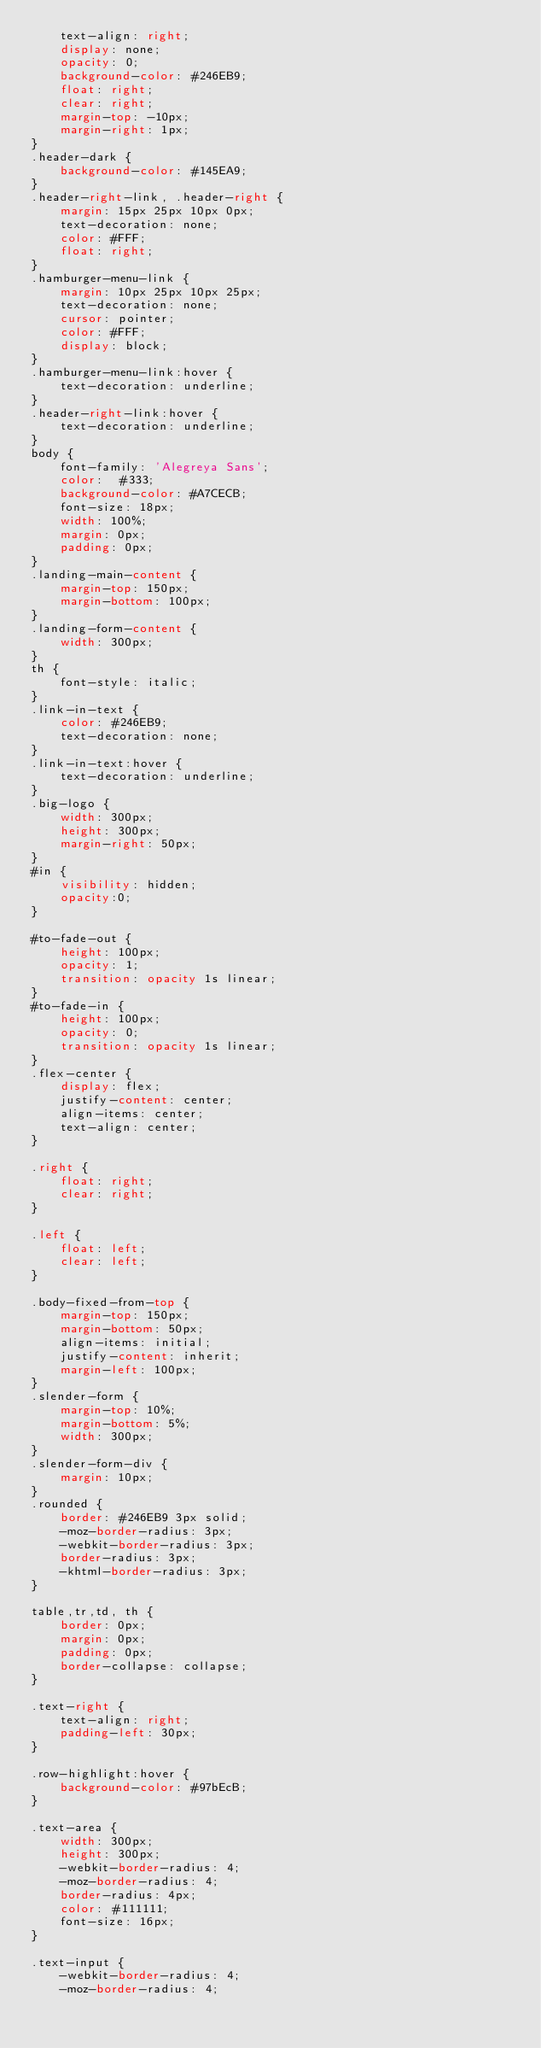<code> <loc_0><loc_0><loc_500><loc_500><_CSS_>    text-align: right;
    display: none;
    opacity: 0;
    background-color: #246EB9;
    float: right;
    clear: right;
    margin-top: -10px;
    margin-right: 1px;
}
.header-dark {
    background-color: #145EA9;
}
.header-right-link, .header-right {
    margin: 15px 25px 10px 0px;
    text-decoration: none;
    color: #FFF;
    float: right;
}
.hamburger-menu-link {
    margin: 10px 25px 10px 25px;
    text-decoration: none;
    cursor: pointer;
    color: #FFF;
    display: block;
}
.hamburger-menu-link:hover {
    text-decoration: underline;
}
.header-right-link:hover {
    text-decoration: underline;
}
body {
    font-family: 'Alegreya Sans';
    color:  #333;
    background-color: #A7CECB;
    font-size: 18px;
    width: 100%;
    margin: 0px;
    padding: 0px;
}
.landing-main-content {
    margin-top: 150px;
    margin-bottom: 100px;
}
.landing-form-content {
    width: 300px;
}
th {
    font-style: italic;
}
.link-in-text {
    color: #246EB9;
    text-decoration: none;
}
.link-in-text:hover {
    text-decoration: underline;
}
.big-logo {
    width: 300px;
    height: 300px;
    margin-right: 50px;
}
#in {
    visibility: hidden;
    opacity:0;
}

#to-fade-out {
    height: 100px;
    opacity: 1;
    transition: opacity 1s linear;
}
#to-fade-in {
    height: 100px;
    opacity: 0;
    transition: opacity 1s linear;
}
.flex-center {
    display: flex;
    justify-content: center;
    align-items: center;
    text-align: center;
}

.right {
    float: right;
    clear: right;
}

.left {
    float: left;
    clear: left;
}

.body-fixed-from-top {
    margin-top: 150px;
    margin-bottom: 50px;
    align-items: initial;
    justify-content: inherit;
    margin-left: 100px;
}
.slender-form {
    margin-top: 10%;
    margin-bottom: 5%;
    width: 300px;
}
.slender-form-div {
    margin: 10px;
}
.rounded {
    border: #246EB9 3px solid;
    -moz-border-radius: 3px;
    -webkit-border-radius: 3px;
    border-radius: 3px;
    -khtml-border-radius: 3px;
}

table,tr,td, th {
    border: 0px;
    margin: 0px;
    padding: 0px;
    border-collapse: collapse;
}

.text-right {
    text-align: right;
    padding-left: 30px;
}

.row-highlight:hover {
    background-color: #97bEcB;
}

.text-area {
    width: 300px;
    height: 300px;
    -webkit-border-radius: 4;
    -moz-border-radius: 4;
    border-radius: 4px;
    color: #111111;
    font-size: 16px;
}

.text-input {
    -webkit-border-radius: 4;
    -moz-border-radius: 4;</code> 